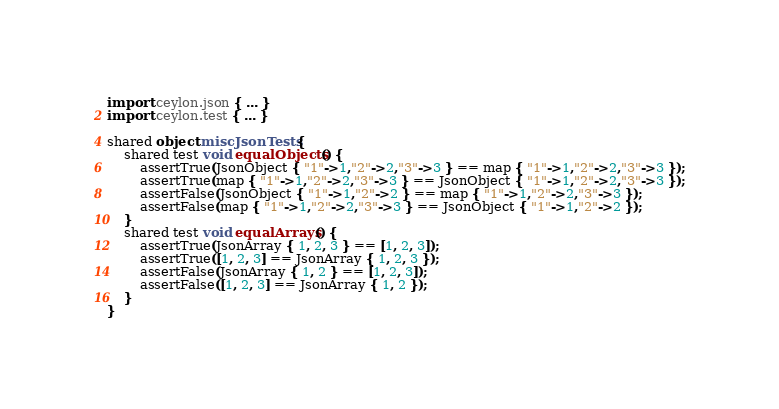<code> <loc_0><loc_0><loc_500><loc_500><_Ceylon_>import ceylon.json { ... }
import ceylon.test { ... }

shared object miscJsonTests {
    shared test void equalObjects() {
        assertTrue(JsonObject { "1"->1,"2"->2,"3"->3 } == map { "1"->1,"2"->2,"3"->3 });
        assertTrue(map { "1"->1,"2"->2,"3"->3 } == JsonObject { "1"->1,"2"->2,"3"->3 });
        assertFalse(JsonObject { "1"->1,"2"->2 } == map { "1"->1,"2"->2,"3"->3 });
        assertFalse(map { "1"->1,"2"->2,"3"->3 } == JsonObject { "1"->1,"2"->2 });
    }
    shared test void equalArrays() {
        assertTrue(JsonArray { 1, 2, 3 } == [1, 2, 3]);
        assertTrue([1, 2, 3] == JsonArray { 1, 2, 3 });
        assertFalse(JsonArray { 1, 2 } == [1, 2, 3]);
        assertFalse([1, 2, 3] == JsonArray { 1, 2 });
    }
}
</code> 